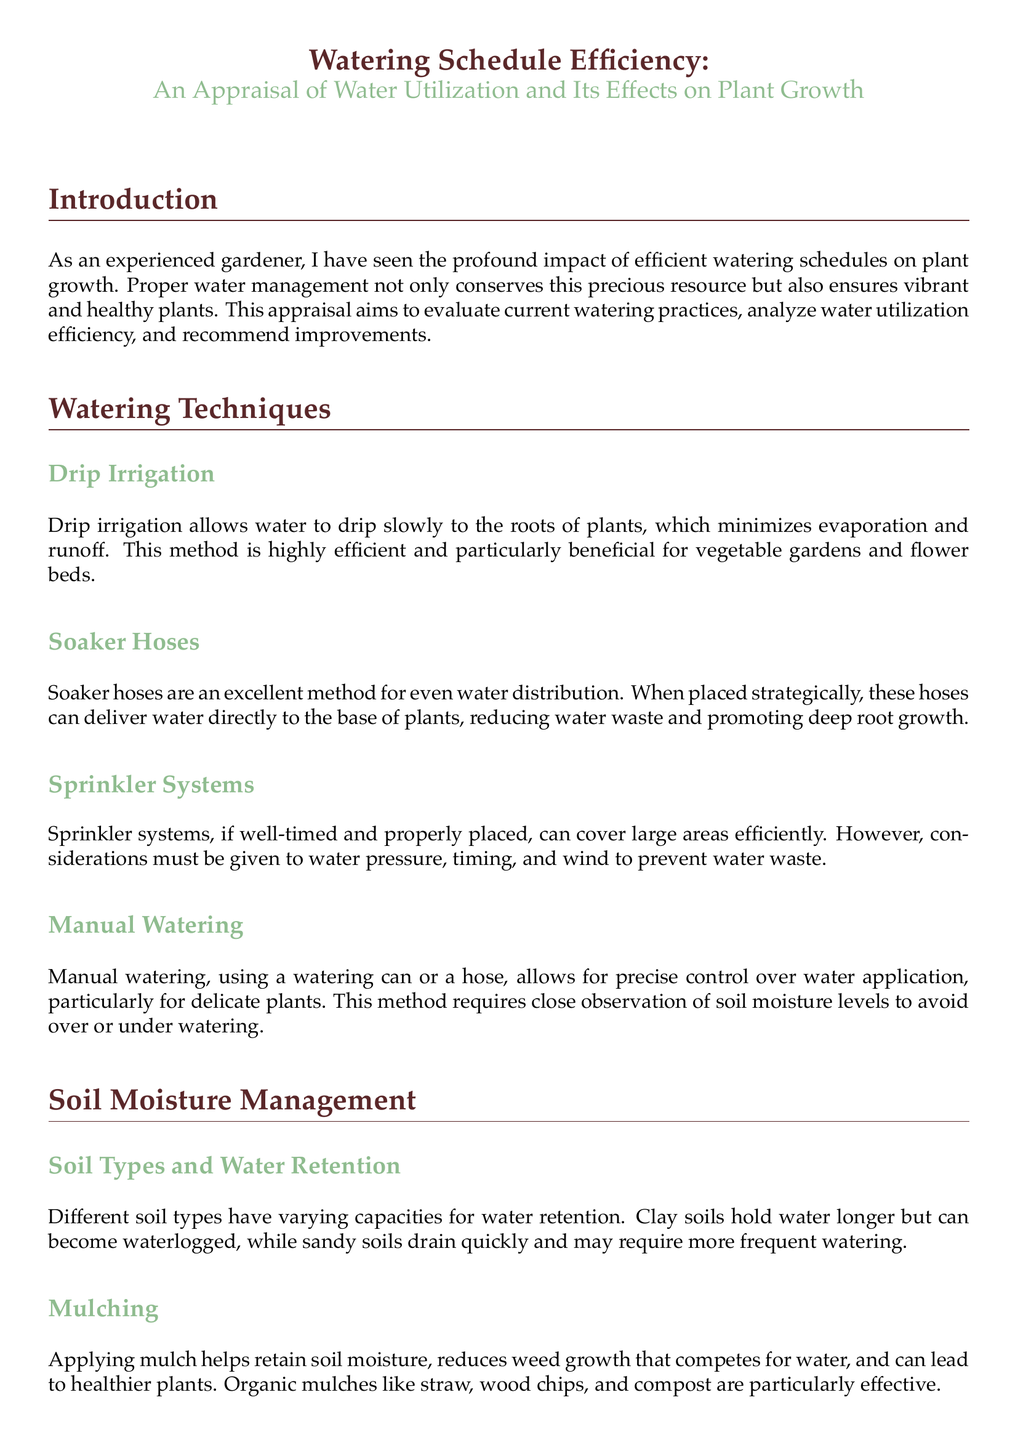What is the title of the document? The title summarizes the theme and focus of the document, presented in a prominent format.
Answer: Watering Schedule Efficiency: An Appraisal of Water Utilization and Its Effects on Plant Growth What is one efficient watering technique mentioned? The document outlines various watering techniques that are efficient for plant growth.
Answer: Drip Irrigation Which soil type holds water longer? The document describes soil types and their water retention capacities, highlighting the characteristics of clay soil.
Answer: Clay What seasonal watering practice is suggested for summer? The document provides specific watering practices suitable for different seasons.
Answer: Water deeply and less frequently What is one benefit of applying mulch? The document lists advantages of using mulch in gardening for water retention and plant health.
Answer: Retains soil moisture How does organic matter affect soil? The document discusses the impact of soil amendments on soil structure and water retention.
Answer: Improves structure During which season should watering be gradually reduced? The document indicates the watering approach as plants start to enter dormancy with specific seasonal guidelines.
Answer: Fall What is stated as a watering method for delicate plants? The document addresses precise watering methods suitable for delicate plants.
Answer: Manual Watering 